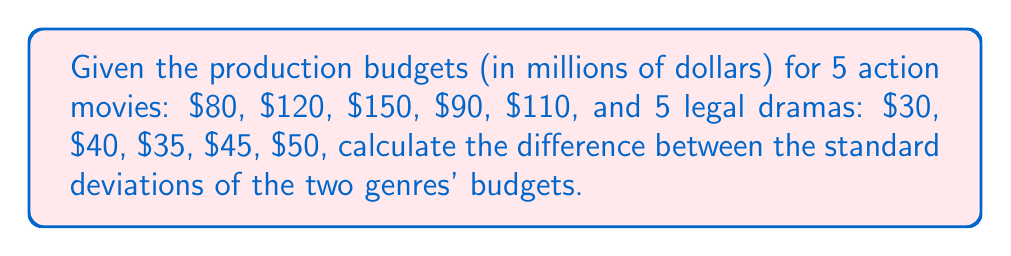Provide a solution to this math problem. Let's calculate the standard deviation for each genre separately:

1. For action movies:

Step 1: Calculate the mean
$\mu_a = \frac{80 + 120 + 150 + 90 + 110}{5} = 110$

Step 2: Calculate the squared differences from the mean
$(80 - 110)^2 = 900$
$(120 - 110)^2 = 100$
$(150 - 110)^2 = 1600$
$(90 - 110)^2 = 400$
$(110 - 110)^2 = 0$

Step 3: Calculate the variance
$\sigma_a^2 = \frac{900 + 100 + 1600 + 400 + 0}{5} = 600$

Step 4: Calculate the standard deviation
$\sigma_a = \sqrt{600} = \sqrt{600} \approx 24.49$

2. For legal dramas:

Step 1: Calculate the mean
$\mu_l = \frac{30 + 40 + 35 + 45 + 50}{5} = 40$

Step 2: Calculate the squared differences from the mean
$(30 - 40)^2 = 100$
$(40 - 40)^2 = 0$
$(35 - 40)^2 = 25$
$(45 - 40)^2 = 25$
$(50 - 40)^2 = 100$

Step 3: Calculate the variance
$\sigma_l^2 = \frac{100 + 0 + 25 + 25 + 100}{5} = 50$

Step 4: Calculate the standard deviation
$\sigma_l = \sqrt{50} \approx 7.07$

3. Calculate the difference between standard deviations:
$\sigma_a - \sigma_l \approx 24.49 - 7.07 \approx 17.42$
Answer: $17.42$ million dollars 